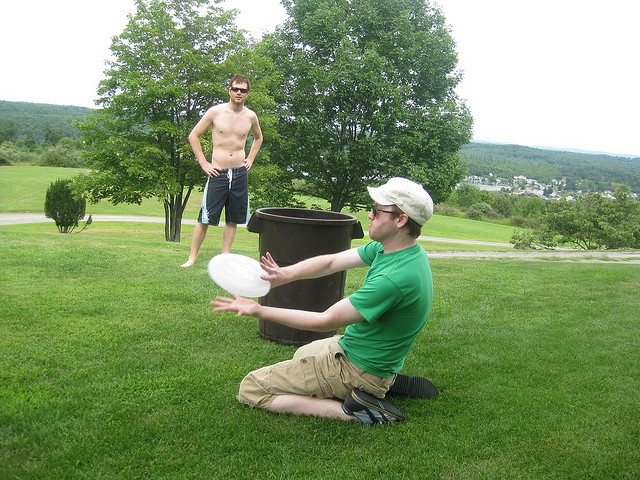Describe the objects in this image and their specific colors. I can see people in white, lightgray, darkgreen, black, and tan tones, people in white, lightgray, tan, and black tones, and frisbee in white, darkgray, beige, and lightgray tones in this image. 